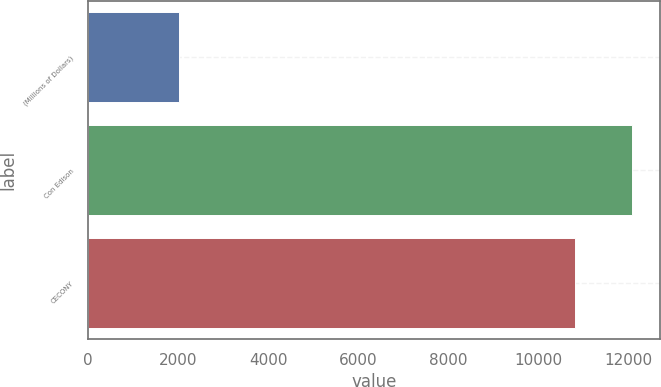<chart> <loc_0><loc_0><loc_500><loc_500><bar_chart><fcel>(Millions of Dollars)<fcel>Con Edison<fcel>CECONY<nl><fcel>2013<fcel>12082<fcel>10797<nl></chart> 